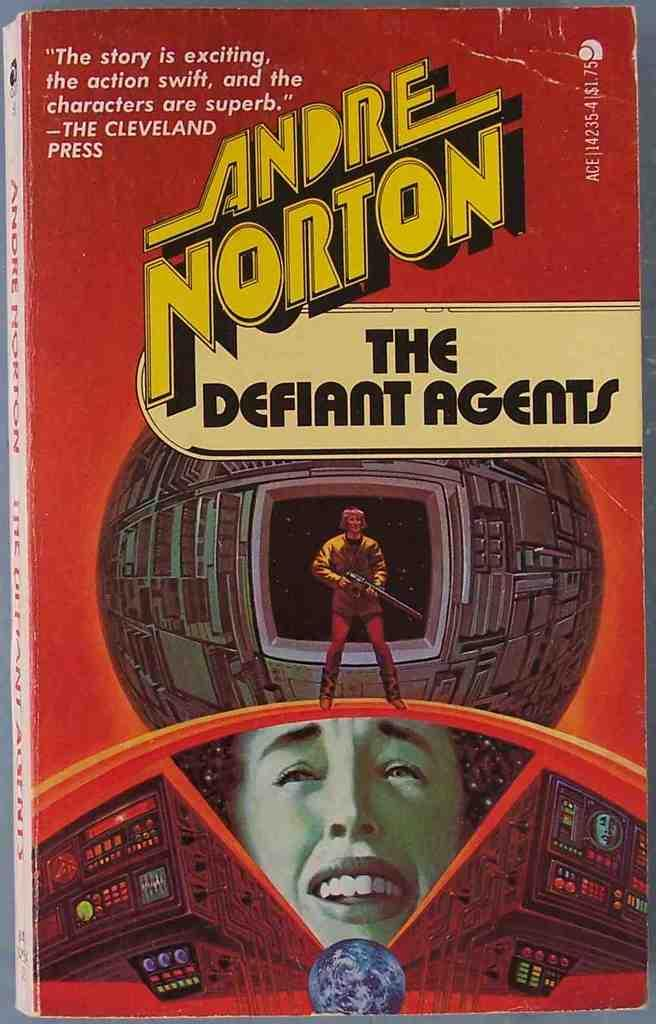<image>
Render a clear and concise summary of the photo. A vintage Science Fiction novel is titled The Defiant Agents. 